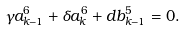Convert formula to latex. <formula><loc_0><loc_0><loc_500><loc_500>\gamma a _ { k - 1 } ^ { 6 } + \delta a _ { k } ^ { 6 } + d b _ { k - 1 } ^ { 5 } = 0 .</formula> 